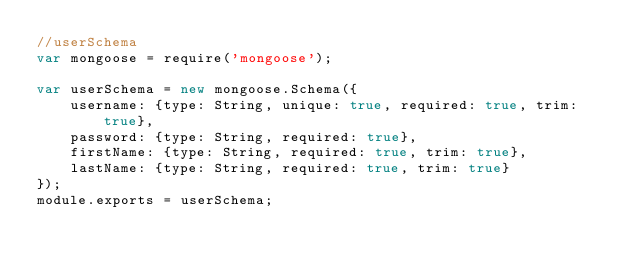Convert code to text. <code><loc_0><loc_0><loc_500><loc_500><_JavaScript_>//userSchema
var mongoose = require('mongoose');

var userSchema = new mongoose.Schema({
    username: {type: String, unique: true, required: true, trim: true},
    password: {type: String, required: true},    
    firstName: {type: String, required: true, trim: true},
    lastName: {type: String, required: true, trim: true}    
});
module.exports = userSchema;

</code> 